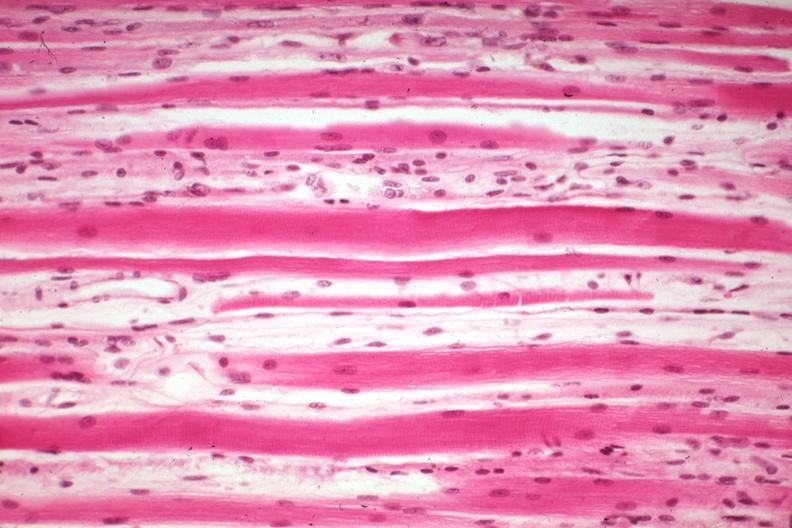what induced atrophy?
Answer the question using a single word or phrase. High excellent steroid 